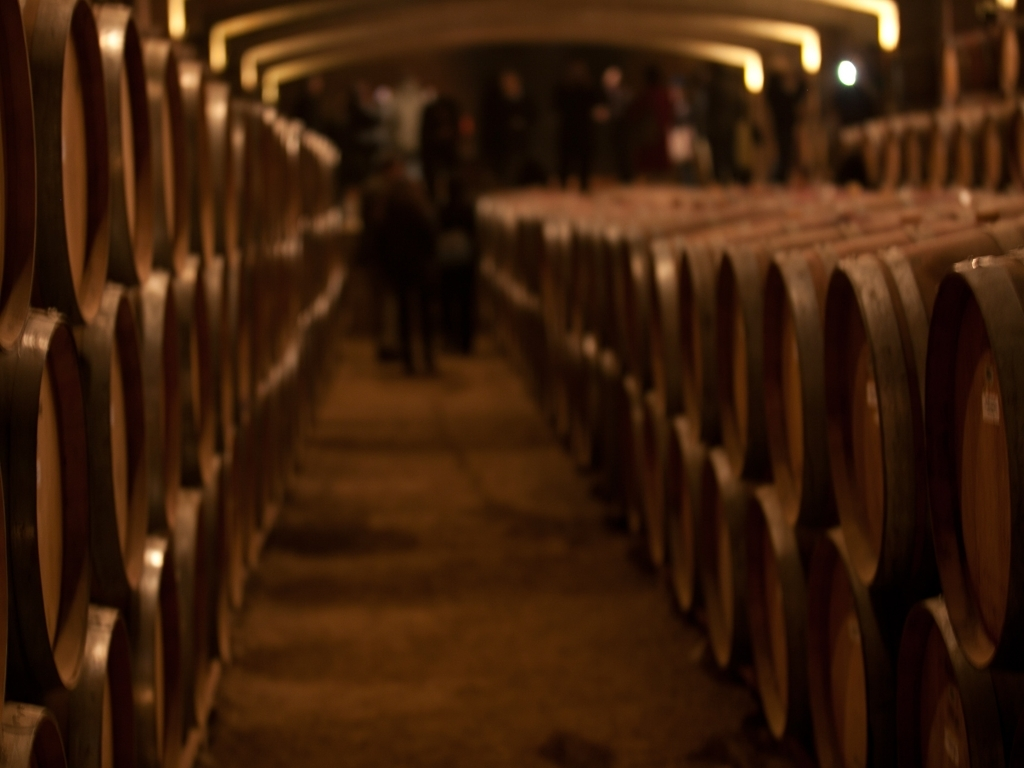What could be the significance of the lighting in this image? The warm, dim lighting in the image suggests that the barrels are stored in a cellar, where steady temperature and limited light exposure are crucial for proper aging. The ambiance created by the lighting enhances the aesthetic of a traditional and serene aging environment. 